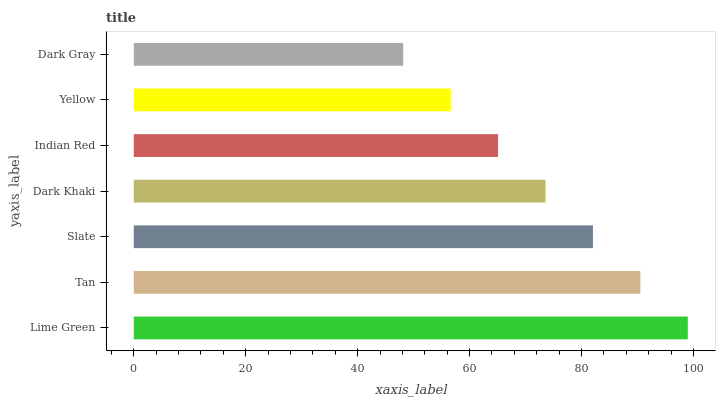Is Dark Gray the minimum?
Answer yes or no. Yes. Is Lime Green the maximum?
Answer yes or no. Yes. Is Tan the minimum?
Answer yes or no. No. Is Tan the maximum?
Answer yes or no. No. Is Lime Green greater than Tan?
Answer yes or no. Yes. Is Tan less than Lime Green?
Answer yes or no. Yes. Is Tan greater than Lime Green?
Answer yes or no. No. Is Lime Green less than Tan?
Answer yes or no. No. Is Dark Khaki the high median?
Answer yes or no. Yes. Is Dark Khaki the low median?
Answer yes or no. Yes. Is Indian Red the high median?
Answer yes or no. No. Is Yellow the low median?
Answer yes or no. No. 